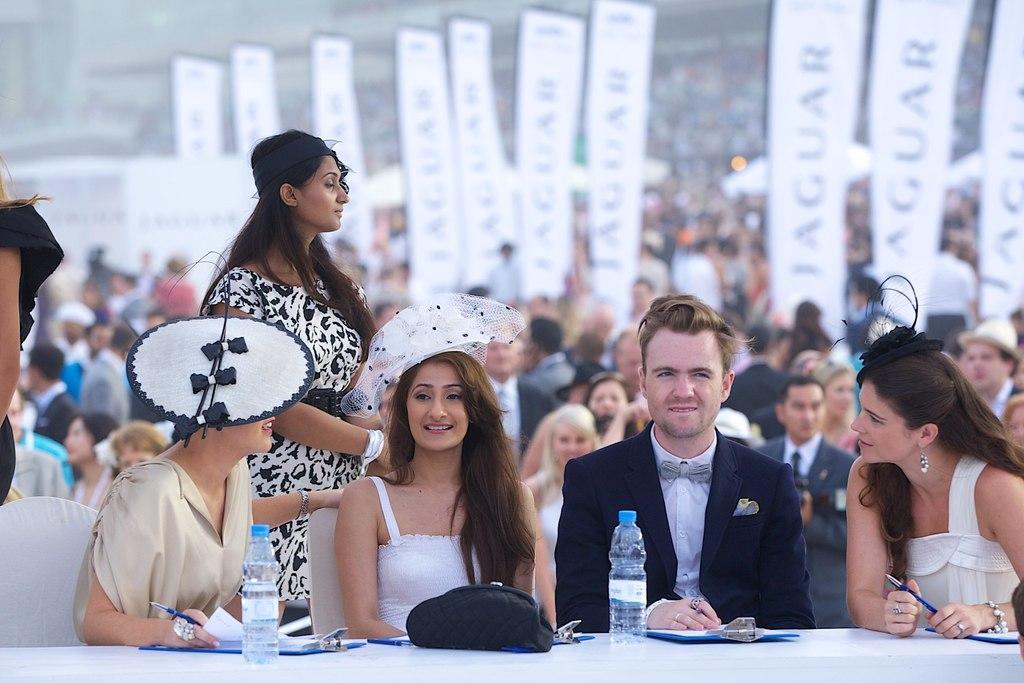Describe this image in one or two sentences. In this picture we can see a few people are sitting on the chair. There are few bottles, bag, notepads and pen on the table. We can see some people are standing on the left side. We can see a few banners in the background. 